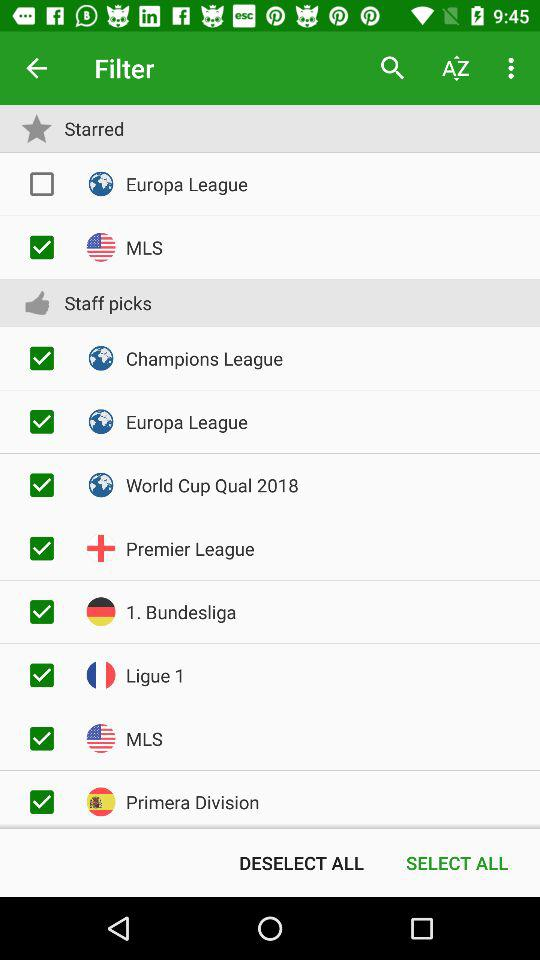Which staff picks is not selected?
When the provided information is insufficient, respond with <no answer>. <no answer> 